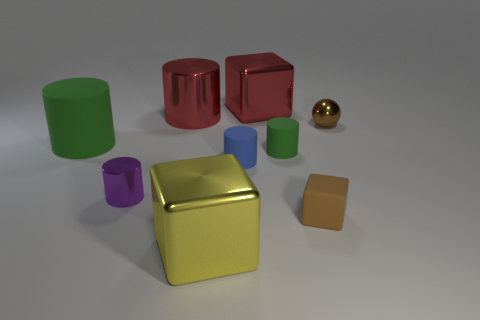Add 1 blue matte objects. How many objects exist? 10 Subtract all balls. How many objects are left? 8 Subtract all blue cylinders. How many cylinders are left? 4 Add 9 purple things. How many purple things exist? 10 Subtract all tiny metal cylinders. How many cylinders are left? 4 Subtract 0 green blocks. How many objects are left? 9 Subtract 2 cylinders. How many cylinders are left? 3 Subtract all purple spheres. Subtract all yellow cubes. How many spheres are left? 1 Subtract all cyan balls. How many red cubes are left? 1 Subtract all red shiny blocks. Subtract all large red metallic cubes. How many objects are left? 7 